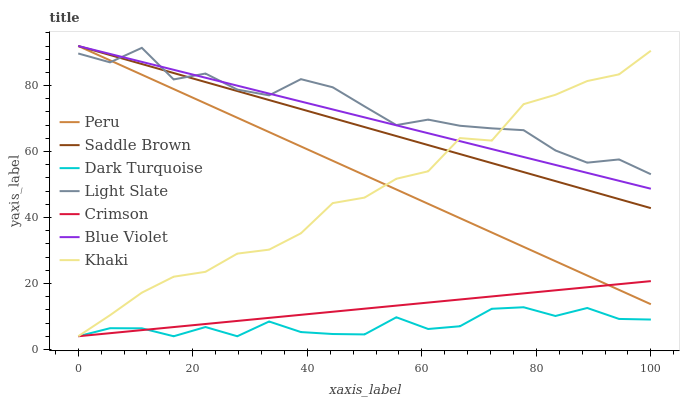Does Light Slate have the minimum area under the curve?
Answer yes or no. No. Does Dark Turquoise have the maximum area under the curve?
Answer yes or no. No. Is Dark Turquoise the smoothest?
Answer yes or no. No. Is Dark Turquoise the roughest?
Answer yes or no. No. Does Light Slate have the lowest value?
Answer yes or no. No. Does Light Slate have the highest value?
Answer yes or no. No. Is Dark Turquoise less than Saddle Brown?
Answer yes or no. Yes. Is Saddle Brown greater than Crimson?
Answer yes or no. Yes. Does Dark Turquoise intersect Saddle Brown?
Answer yes or no. No. 